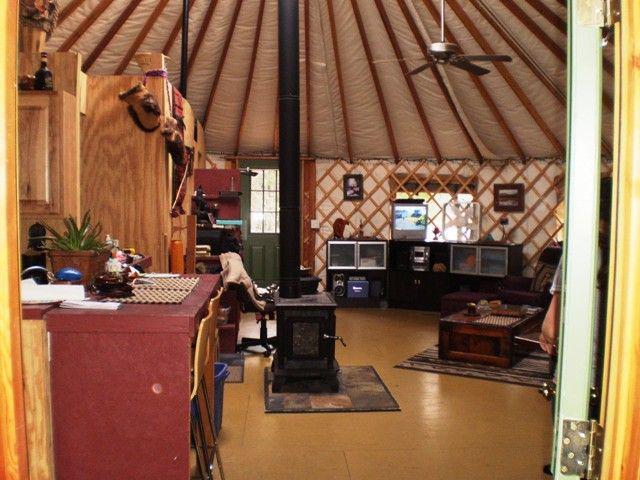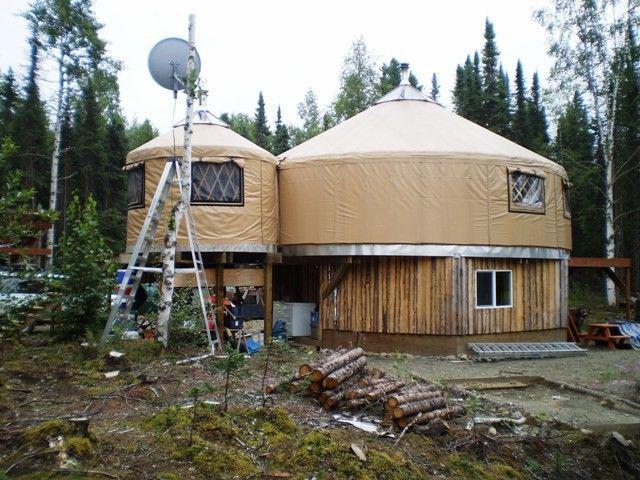The first image is the image on the left, the second image is the image on the right. For the images displayed, is the sentence "Multiple people are visible outside one of the tents/yurts." factually correct? Answer yes or no. No. 